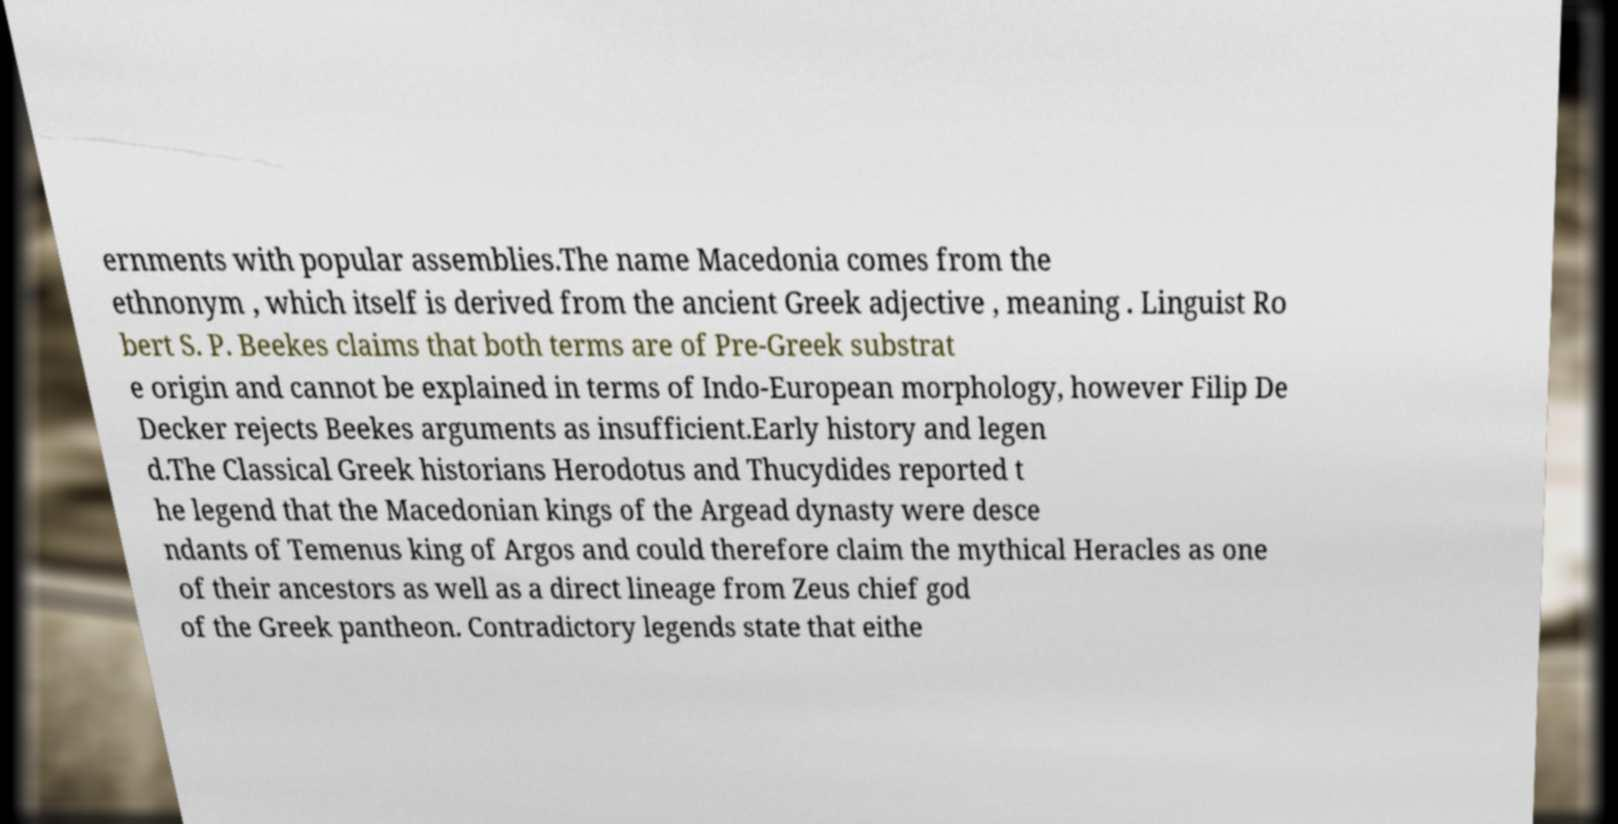Please read and relay the text visible in this image. What does it say? ernments with popular assemblies.The name Macedonia comes from the ethnonym , which itself is derived from the ancient Greek adjective , meaning . Linguist Ro bert S. P. Beekes claims that both terms are of Pre-Greek substrat e origin and cannot be explained in terms of Indo-European morphology, however Filip De Decker rejects Beekes arguments as insufficient.Early history and legen d.The Classical Greek historians Herodotus and Thucydides reported t he legend that the Macedonian kings of the Argead dynasty were desce ndants of Temenus king of Argos and could therefore claim the mythical Heracles as one of their ancestors as well as a direct lineage from Zeus chief god of the Greek pantheon. Contradictory legends state that eithe 